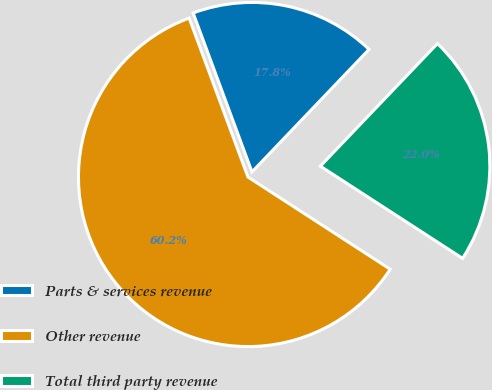Convert chart to OTSL. <chart><loc_0><loc_0><loc_500><loc_500><pie_chart><fcel>Parts & services revenue<fcel>Other revenue<fcel>Total third party revenue<nl><fcel>17.78%<fcel>60.21%<fcel>22.02%<nl></chart> 